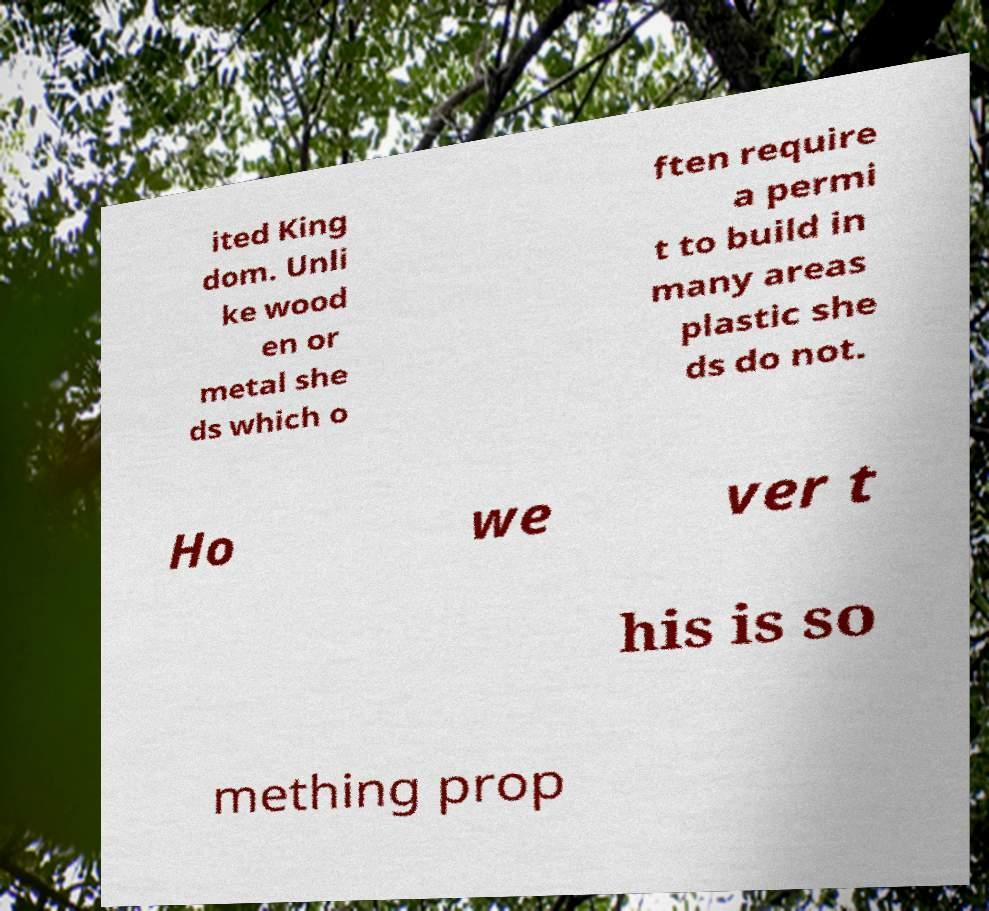For documentation purposes, I need the text within this image transcribed. Could you provide that? ited King dom. Unli ke wood en or metal she ds which o ften require a permi t to build in many areas plastic she ds do not. Ho we ver t his is so mething prop 